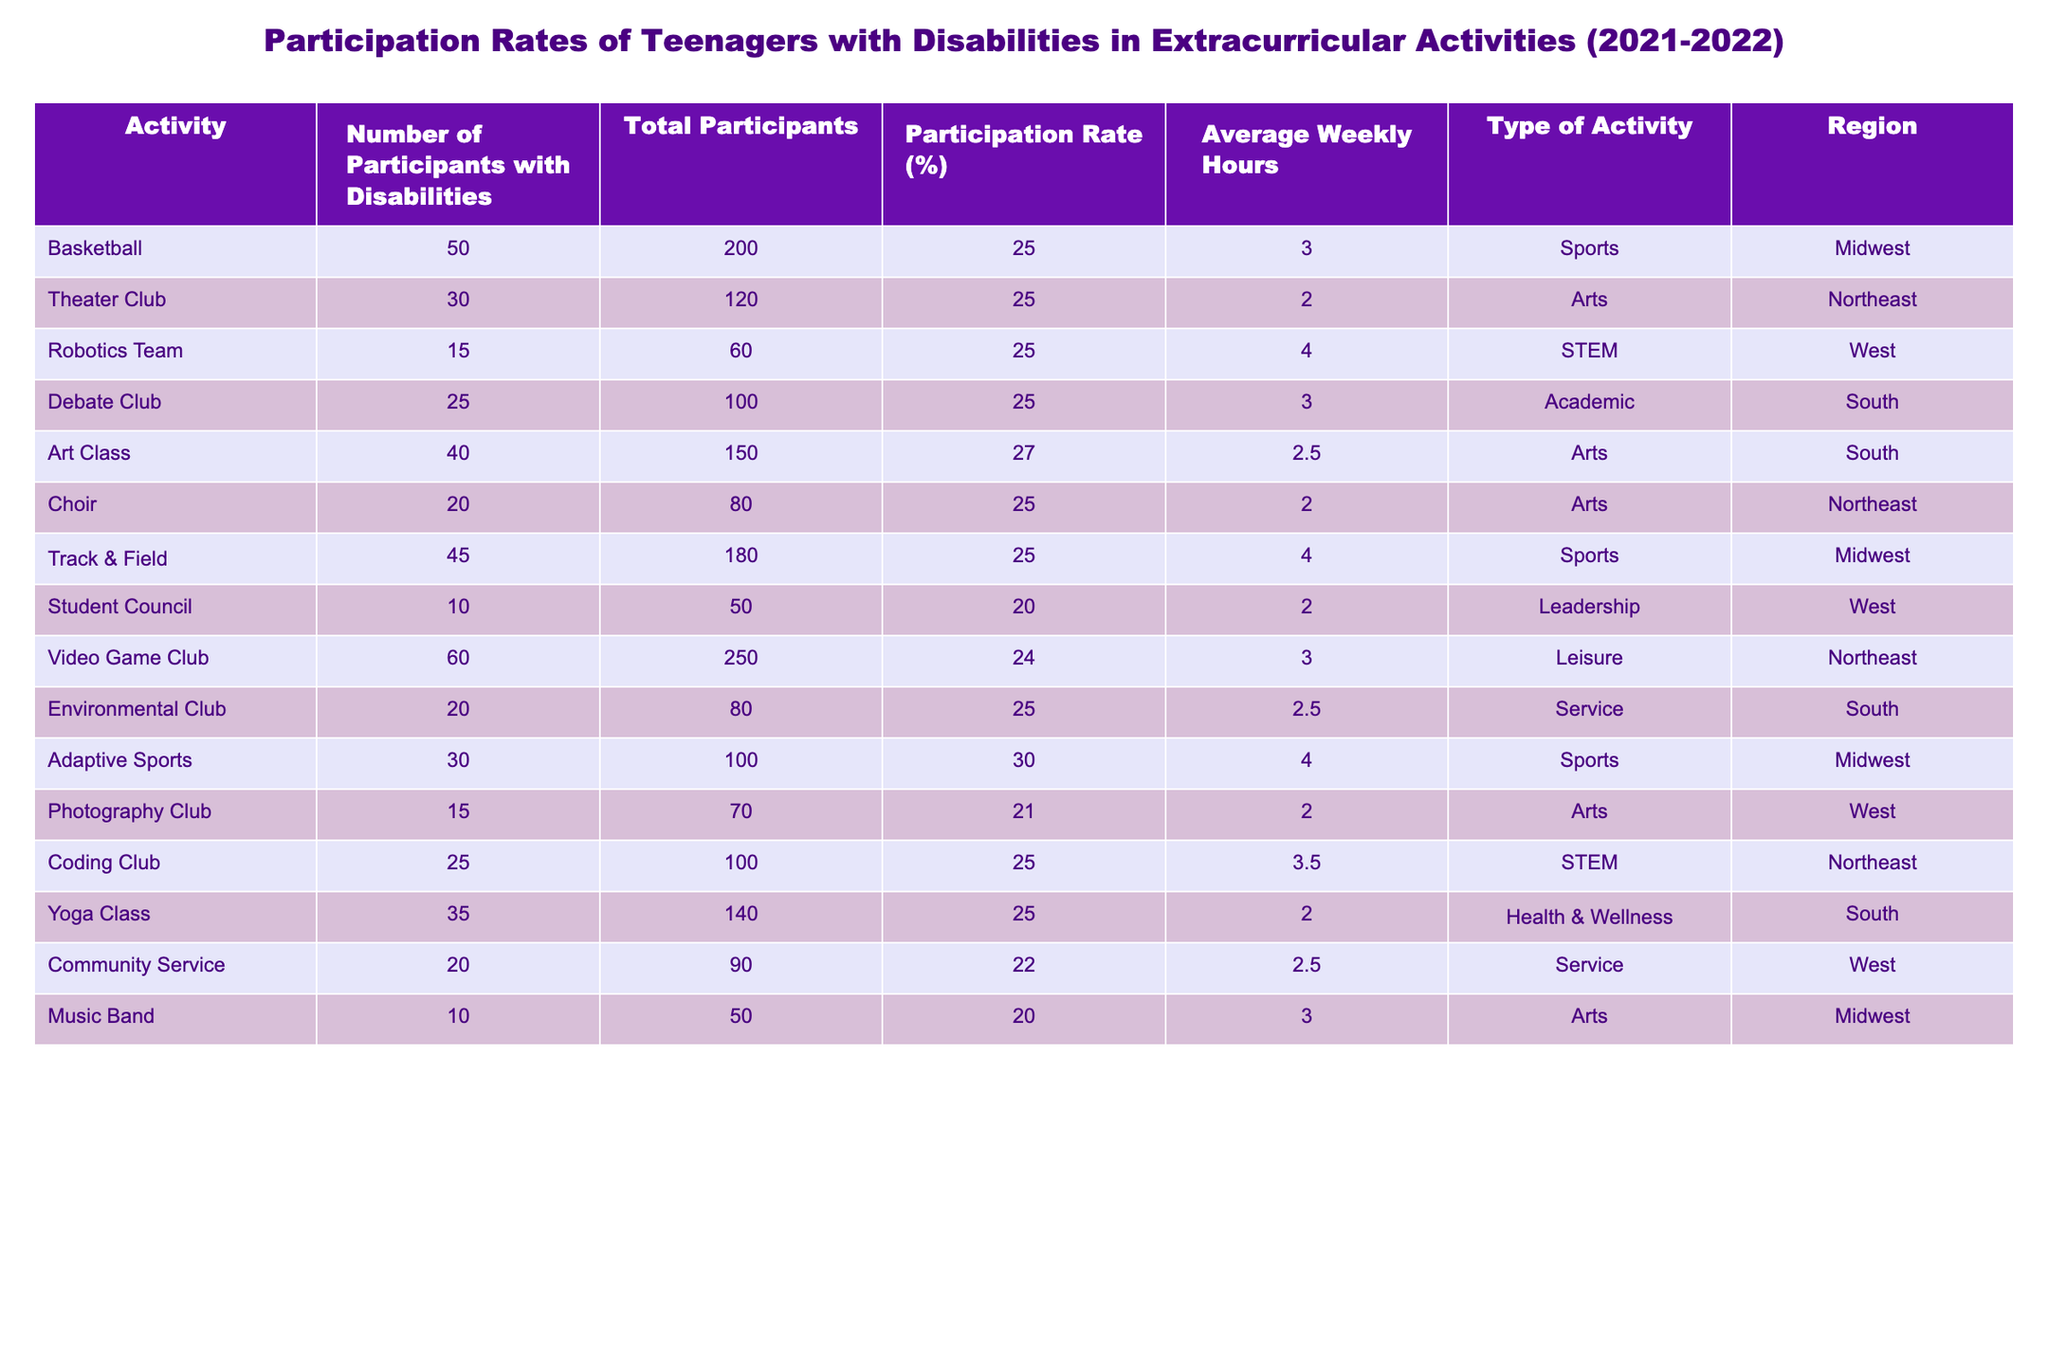What is the participation rate of the Theater Club? The participation rate of the Theater Club can be directly found in the table under the "Participation Rate (%)" column corresponding to "Theater Club," which shows 25%.
Answer: 25% How many participants with disabilities are in the Video Game Club? The number of participants with disabilities in the Video Game Club is stated in the "Number of Participants with Disabilities" column for that activity, which shows 60.
Answer: 60 Which activity has the highest participation rate? To find the activity with the highest participation rate, I look through the "Participation Rate (%)" column and see that Adaptive Sports has the highest rate of 30%.
Answer: Adaptive Sports What is the average number of weekly hours teenagers with disabilities spend in the Art Class and the Theater Club combined? The average weekly hours for Art Class is 2.5 and for Theater Club is 2. Adding both gives 4.5. When calculating the average, divide by the number of activities (2): 4.5/2 = 2.25.
Answer: 2.25 Are there more participants with disabilities in Choir than in Music Band? I compare the "Number of Participants with Disabilities" for both Choir (20) and Music Band (10). Since 20 is greater than 10, the answer is yes.
Answer: Yes What is the total number of weekly hours for the Robotics Team and the Coding Club? The Robotics Team has 4 average weekly hours and the Coding Club has 3.5. Adding these gives a total of 4 + 3.5 = 7.5.
Answer: 7.5 In which region is the Environmental Club located, and what is its participation rate? I look for the Environmental Club in the table, which shows it is located in the South with a participation rate of 25%.
Answer: South, 25% What is the median participation rate of all activities listed? I gather the participation rates: 25, 25, 25, 25, 27, 25, 25, 20, 24, 25, 30, 21, 25, 25, 22, 20. After sorting the rates, the median (middle value) is 25, as there are 16 values, and the average of the two middle values (25 and 25) is also 25.
Answer: 25 Which type of activity has the lowest average participation rate among its members? To find the type with the lowest average participation rate, I group the activities by type, calculate each average, and find the lowest. Leadership has the lowest average at 20%.
Answer: Leadership Does Track & Field have a higher average weekly hour commitment compared to the Yoga Class? Track & Field has 4 average weekly hours while Yoga Class has 2. Since 4 is greater than 2, Track & Field has a higher commitment.
Answer: Yes 